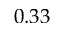<formula> <loc_0><loc_0><loc_500><loc_500>0 . 3 3</formula> 